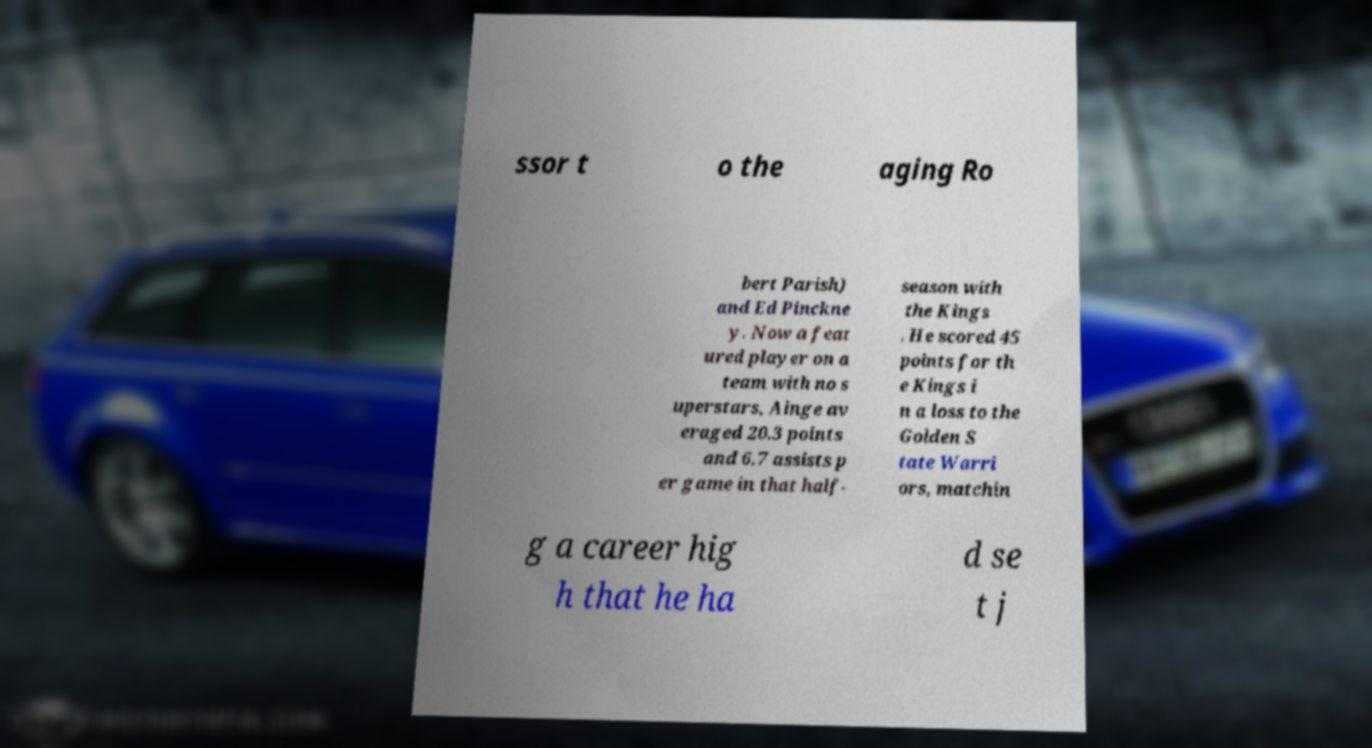There's text embedded in this image that I need extracted. Can you transcribe it verbatim? ssor t o the aging Ro bert Parish) and Ed Pinckne y. Now a feat ured player on a team with no s uperstars, Ainge av eraged 20.3 points and 6.7 assists p er game in that half- season with the Kings . He scored 45 points for th e Kings i n a loss to the Golden S tate Warri ors, matchin g a career hig h that he ha d se t j 